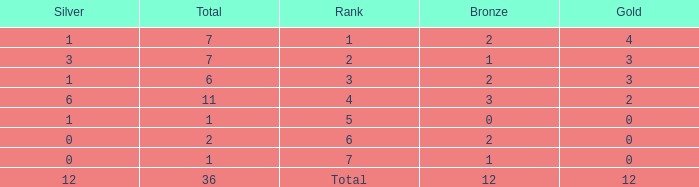What is the largest total for a team with fewer than 12 bronze, 1 silver and 0 gold medals? 1.0. 